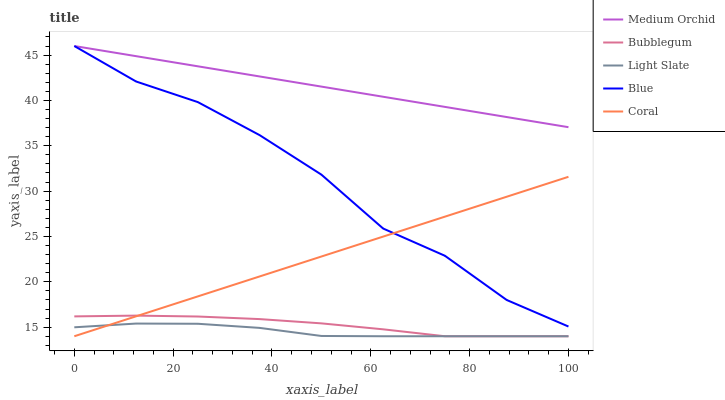Does Light Slate have the minimum area under the curve?
Answer yes or no. Yes. Does Medium Orchid have the maximum area under the curve?
Answer yes or no. Yes. Does Blue have the minimum area under the curve?
Answer yes or no. No. Does Blue have the maximum area under the curve?
Answer yes or no. No. Is Coral the smoothest?
Answer yes or no. Yes. Is Blue the roughest?
Answer yes or no. Yes. Is Blue the smoothest?
Answer yes or no. No. Is Coral the roughest?
Answer yes or no. No. Does Light Slate have the lowest value?
Answer yes or no. Yes. Does Blue have the lowest value?
Answer yes or no. No. Does Medium Orchid have the highest value?
Answer yes or no. Yes. Does Coral have the highest value?
Answer yes or no. No. Is Light Slate less than Blue?
Answer yes or no. Yes. Is Medium Orchid greater than Light Slate?
Answer yes or no. Yes. Does Coral intersect Blue?
Answer yes or no. Yes. Is Coral less than Blue?
Answer yes or no. No. Is Coral greater than Blue?
Answer yes or no. No. Does Light Slate intersect Blue?
Answer yes or no. No. 